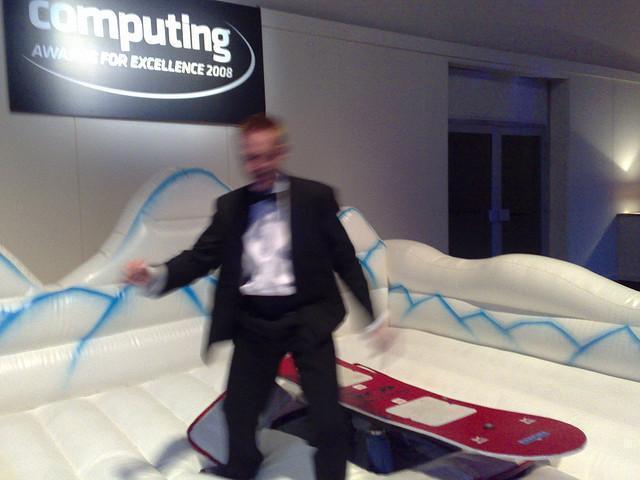The inflatable display is meant to simulate which winter sport?
Indicate the correct choice and explain in the format: 'Answer: answer
Rationale: rationale.'
Options: Skiing, snowboarding, curling, ice skating. Answer: snowboarding.
Rationale: The inflatable is snowboarding. 